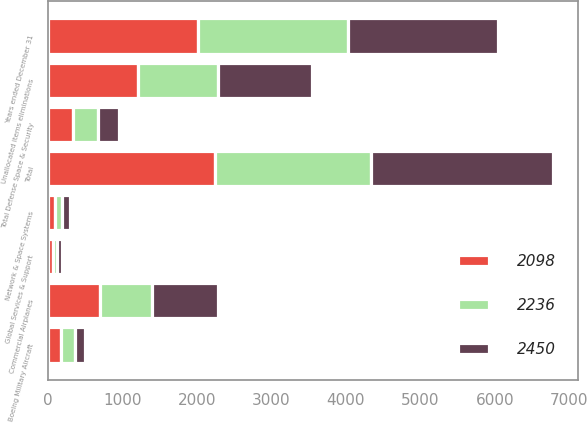Convert chart. <chart><loc_0><loc_0><loc_500><loc_500><stacked_bar_chart><ecel><fcel>Years ended December 31<fcel>Commercial Airplanes<fcel>Boeing Military Aircraft<fcel>Network & Space Systems<fcel>Global Services & Support<fcel>Total Defense Space & Security<fcel>Unallocated items eliminations<fcel>Total<nl><fcel>2450<fcel>2015<fcel>889<fcel>128<fcel>98<fcel>62<fcel>288<fcel>1273<fcel>2450<nl><fcel>2098<fcel>2014<fcel>698<fcel>175<fcel>93<fcel>68<fcel>336<fcel>1202<fcel>2236<nl><fcel>2236<fcel>2013<fcel>694<fcel>186<fcel>96<fcel>48<fcel>330<fcel>1074<fcel>2098<nl></chart> 